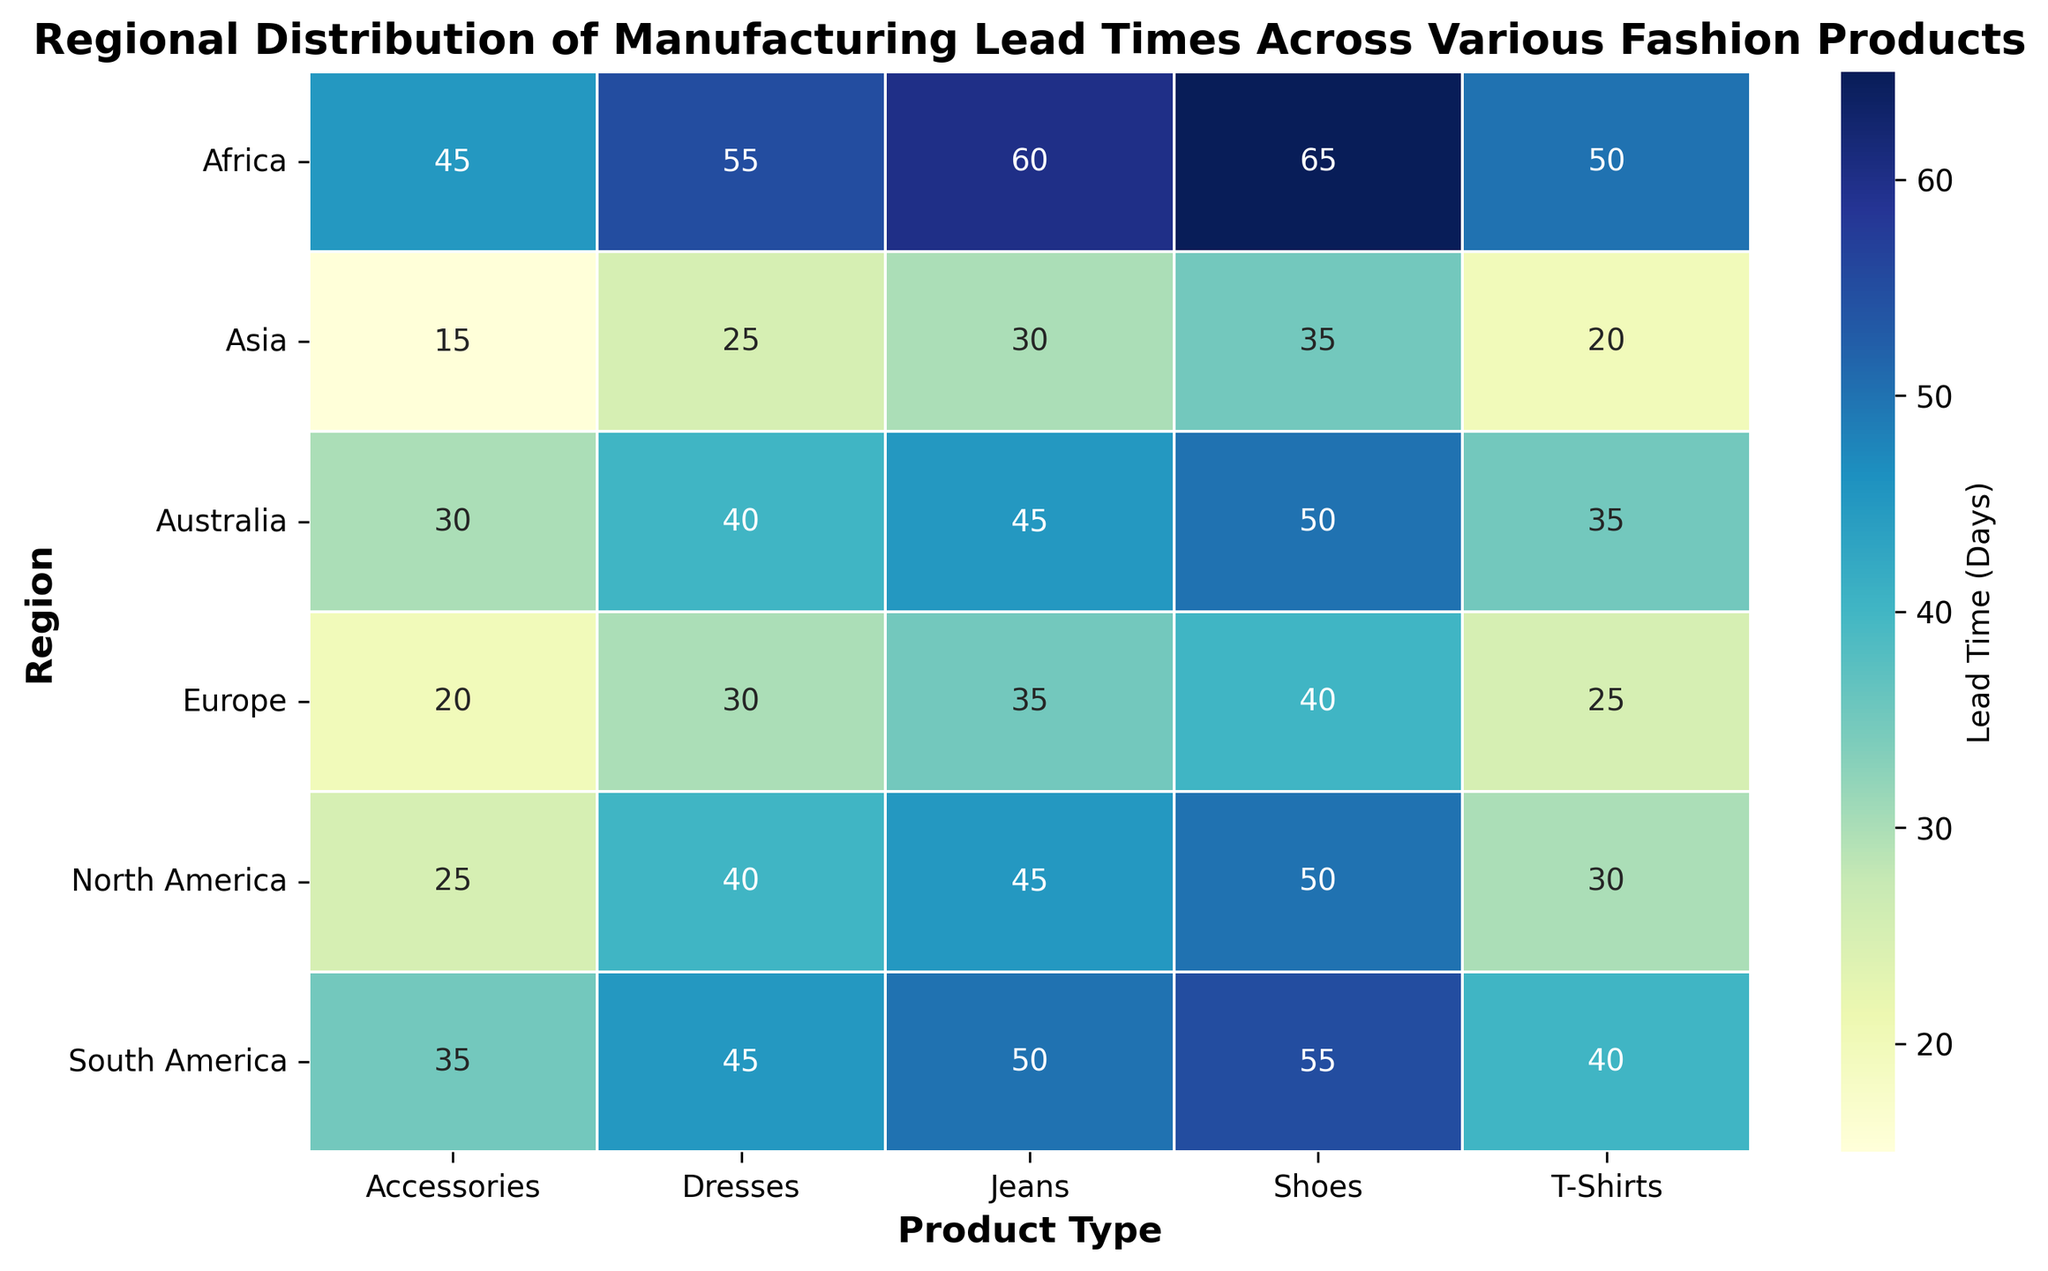What region has the shortest average lead time across all product types? Calculate the average lead time for each region by adding the lead times of all products and dividing by the number of products. For North America: (30+45+40+50+25)/5 = 38. For Europe: (25+35+30+40+20)/5 = 30. For Asia: (20+30+25+35+15)/5 = 25. For South America: (40+50+45+55+35)/5 = 45. For Africa: (50+60+55+65+45)/5 = 55. For Australia: (35+45+40+50+30)/5 = 40. Asia has the shortest lead time.
Answer: Asia Which product type has the longest lead time in North America? Identify the product type with the highest lead time in the "North America" row. Shoes have a lead time of 50 days, which is the longest.
Answer: Shoes How does the lead time for T-Shirts in North America compare to that in Europe? Refer to the lead times for T-Shirts in North America and Europe. North America has 30 days and Europe has 25 days. North America's lead time is 5 days longer.
Answer: 5 days longer Which region shows the greatest variation in lead times across different products? Calculate the range (difference between the maximum and minimum lead times) for each region. North America: 50-25=25. Europe: 40-20=20. Asia: 35-15=20. South America: 55-35=20. Africa: 65-45=20. Australia: 50-30=20. North America has the greatest variation of 25 days.
Answer: North America What is the average lead time for shoes across all regions? Add the lead times for shoes in all regions and divide by the number of regions. (50+40+35+55+65+50)/6 = 295/6 ≈ 49.17.
Answer: 49.17 How many product types in Africa have a lead time greater than 50 days? Refer to the "Africa" row and count the number of product types with lead times greater than 50 days. There are 3: Jeans (60), Dresses (55), and Shoes (65).
Answer: 3 Which product type has the smallest range in lead times across all regions? Calculate the range for each product type by subtracting the minimum lead time from the maximum lead time. T-Shirts: 50-20=30. Jeans: 60-30=30. Dresses: 55-25=30. Shoes: 65-35=30. Accessories: 45-15=30. All product types have the same range of 30 days.
Answer: All equal Which region has the longest lead time for Accessories? Identify the maximum value for Accessories across all regions. Africa has the highest lead time of 45 days.
Answer: Africa What is the total lead time for all types of fashion products in Europe? Sum the lead times of all products in the "Europe" row. 25 + 35 + 30 + 40 + 20 = 150.
Answer: 150 If the lead time for T-Shirts in Africa is reduced by 10 days, what will be the new average lead time for Africa? Subtract 10 days from the Africa T-Shirts lead time, making it 40. Then, recalculate the average lead time: (40 + 60 + 55 + 65 + 45) / 5 = 265 / 5 = 53.
Answer: 53 